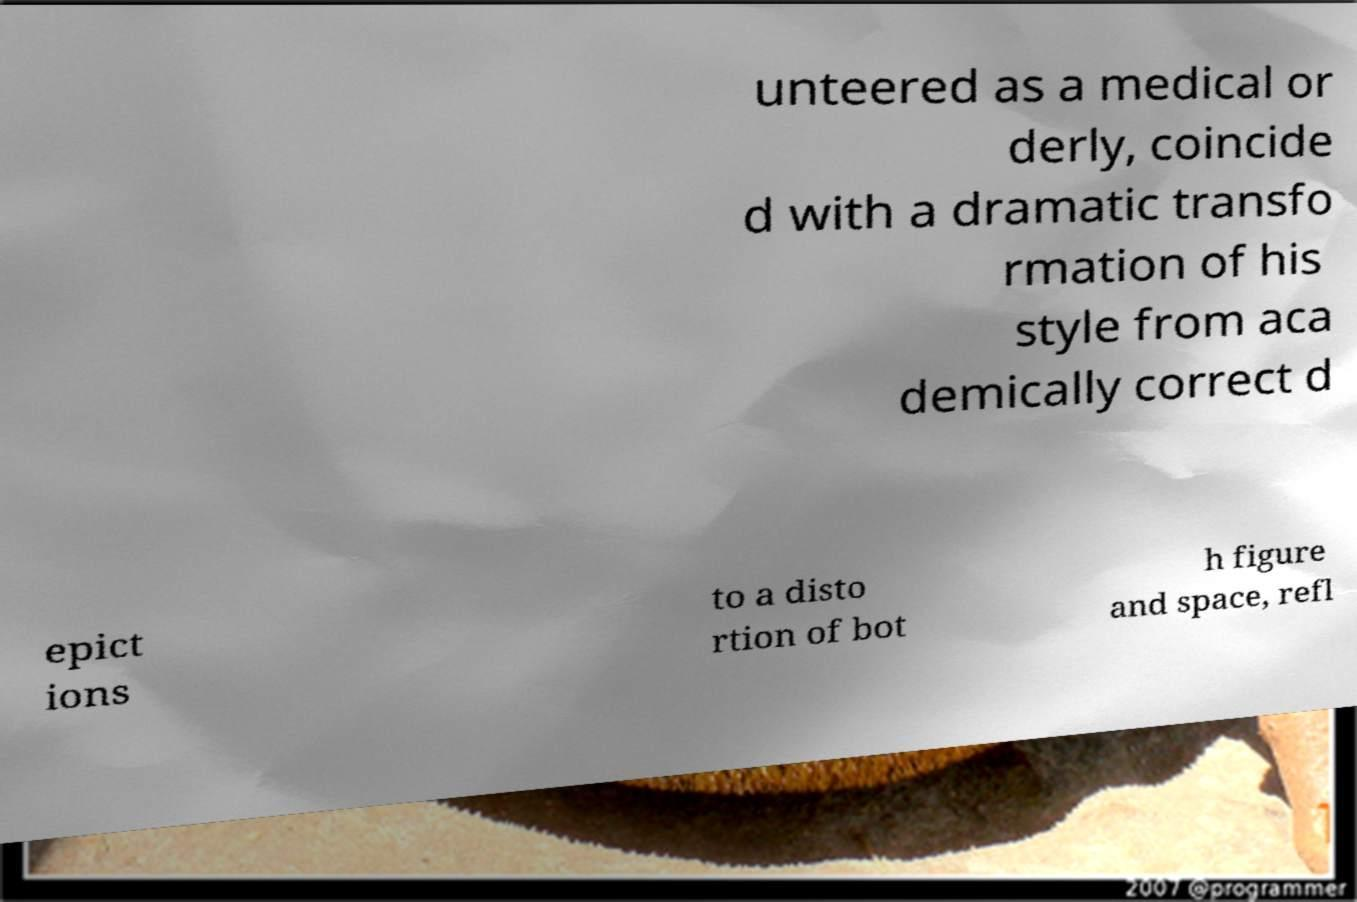Please identify and transcribe the text found in this image. unteered as a medical or derly, coincide d with a dramatic transfo rmation of his style from aca demically correct d epict ions to a disto rtion of bot h figure and space, refl 